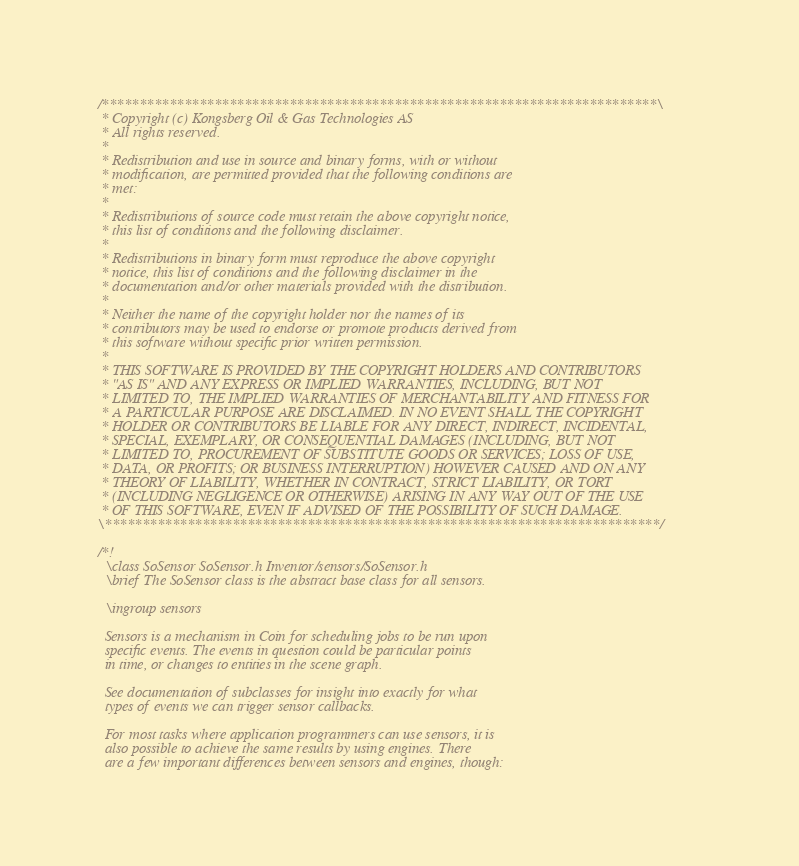<code> <loc_0><loc_0><loc_500><loc_500><_C++_>/**************************************************************************\
 * Copyright (c) Kongsberg Oil & Gas Technologies AS
 * All rights reserved.
 * 
 * Redistribution and use in source and binary forms, with or without
 * modification, are permitted provided that the following conditions are
 * met:
 * 
 * Redistributions of source code must retain the above copyright notice,
 * this list of conditions and the following disclaimer.
 * 
 * Redistributions in binary form must reproduce the above copyright
 * notice, this list of conditions and the following disclaimer in the
 * documentation and/or other materials provided with the distribution.
 * 
 * Neither the name of the copyright holder nor the names of its
 * contributors may be used to endorse or promote products derived from
 * this software without specific prior written permission.
 * 
 * THIS SOFTWARE IS PROVIDED BY THE COPYRIGHT HOLDERS AND CONTRIBUTORS
 * "AS IS" AND ANY EXPRESS OR IMPLIED WARRANTIES, INCLUDING, BUT NOT
 * LIMITED TO, THE IMPLIED WARRANTIES OF MERCHANTABILITY AND FITNESS FOR
 * A PARTICULAR PURPOSE ARE DISCLAIMED. IN NO EVENT SHALL THE COPYRIGHT
 * HOLDER OR CONTRIBUTORS BE LIABLE FOR ANY DIRECT, INDIRECT, INCIDENTAL,
 * SPECIAL, EXEMPLARY, OR CONSEQUENTIAL DAMAGES (INCLUDING, BUT NOT
 * LIMITED TO, PROCUREMENT OF SUBSTITUTE GOODS OR SERVICES; LOSS OF USE,
 * DATA, OR PROFITS; OR BUSINESS INTERRUPTION) HOWEVER CAUSED AND ON ANY
 * THEORY OF LIABILITY, WHETHER IN CONTRACT, STRICT LIABILITY, OR TORT
 * (INCLUDING NEGLIGENCE OR OTHERWISE) ARISING IN ANY WAY OUT OF THE USE
 * OF THIS SOFTWARE, EVEN IF ADVISED OF THE POSSIBILITY OF SUCH DAMAGE.
\**************************************************************************/

/*!
  \class SoSensor SoSensor.h Inventor/sensors/SoSensor.h
  \brief The SoSensor class is the abstract base class for all sensors.

  \ingroup sensors

  Sensors is a mechanism in Coin for scheduling jobs to be run upon
  specific events. The events in question could be particular points
  in time, or changes to entities in the scene graph.

  See documentation of subclasses for insight into exactly for what
  types of events we can trigger sensor callbacks.

  For most tasks where application programmers can use sensors, it is
  also possible to achieve the same results by using engines. There
  are a few important differences between sensors and engines, though:
</code> 